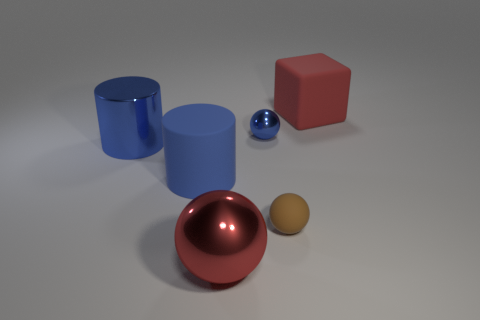What color is the other large thing that is the same shape as the brown object?
Your answer should be compact. Red. Are there any other things that are the same color as the small rubber ball?
Your response must be concise. No. There is a red thing that is to the left of the large red rubber cube; is it the same size as the brown object that is to the right of the tiny metallic ball?
Give a very brief answer. No. Are there an equal number of large cylinders that are right of the small brown thing and big blue cylinders that are to the left of the red cube?
Your answer should be compact. No. Is the size of the red metallic object the same as the brown matte object that is in front of the large blue shiny object?
Keep it short and to the point. No. Is there a thing that is on the right side of the red thing that is to the left of the big red rubber block?
Your answer should be compact. Yes. Is there a tiny brown matte thing that has the same shape as the large blue matte thing?
Ensure brevity in your answer.  No. How many blue shiny spheres are left of the big matte object in front of the large red object right of the tiny brown rubber object?
Provide a short and direct response. 0. There is a big ball; is it the same color as the large matte thing behind the small blue metallic object?
Your answer should be compact. Yes. How many objects are either shiny spheres that are in front of the large metal cylinder or large matte things right of the tiny shiny thing?
Ensure brevity in your answer.  2. 